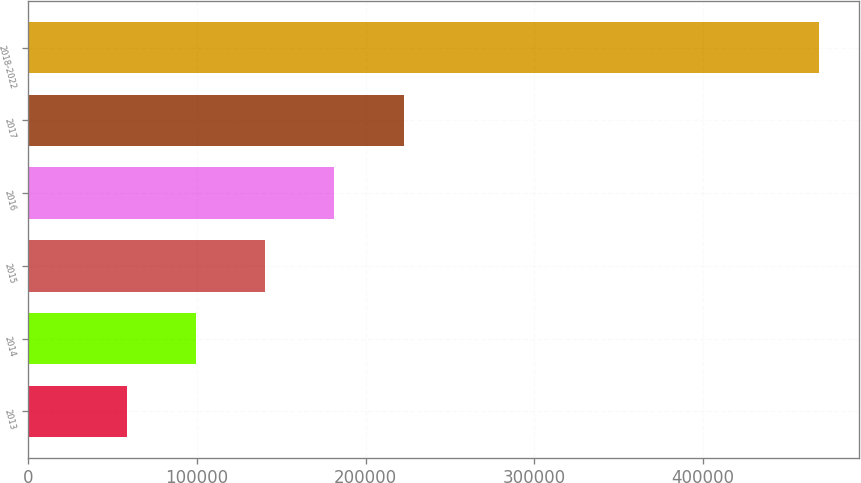Convert chart. <chart><loc_0><loc_0><loc_500><loc_500><bar_chart><fcel>2013<fcel>2014<fcel>2015<fcel>2016<fcel>2017<fcel>2018-2022<nl><fcel>58530<fcel>99556.1<fcel>140582<fcel>181608<fcel>222634<fcel>468791<nl></chart> 